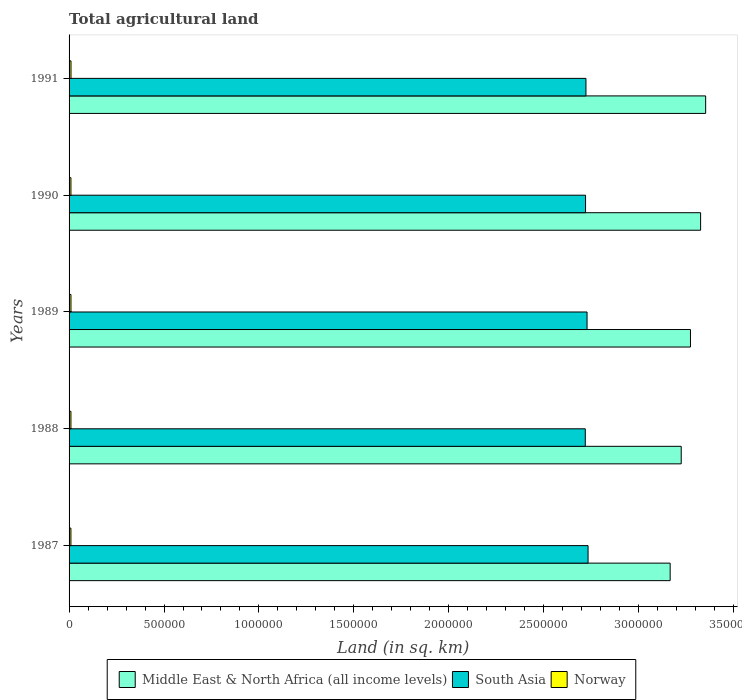Are the number of bars per tick equal to the number of legend labels?
Offer a very short reply. Yes. Are the number of bars on each tick of the Y-axis equal?
Provide a short and direct response. Yes. In how many cases, is the number of bars for a given year not equal to the number of legend labels?
Make the answer very short. 0. What is the total agricultural land in Norway in 1987?
Offer a terse response. 9700. Across all years, what is the maximum total agricultural land in Middle East & North Africa (all income levels)?
Provide a succinct answer. 3.35e+06. Across all years, what is the minimum total agricultural land in South Asia?
Your answer should be very brief. 2.72e+06. In which year was the total agricultural land in Middle East & North Africa (all income levels) minimum?
Give a very brief answer. 1987. What is the total total agricultural land in Norway in the graph?
Ensure brevity in your answer.  4.92e+04. What is the difference between the total agricultural land in Norway in 1987 and that in 1988?
Offer a terse response. -60. What is the difference between the total agricultural land in Middle East & North Africa (all income levels) in 1987 and the total agricultural land in South Asia in 1988?
Ensure brevity in your answer.  4.47e+05. What is the average total agricultural land in South Asia per year?
Offer a terse response. 2.72e+06. In the year 1989, what is the difference between the total agricultural land in Middle East & North Africa (all income levels) and total agricultural land in South Asia?
Ensure brevity in your answer.  5.45e+05. In how many years, is the total agricultural land in South Asia greater than 3000000 sq.km?
Make the answer very short. 0. What is the ratio of the total agricultural land in South Asia in 1987 to that in 1990?
Offer a very short reply. 1. Is the total agricultural land in Norway in 1989 less than that in 1991?
Ensure brevity in your answer.  Yes. What is the difference between the highest and the second highest total agricultural land in Middle East & North Africa (all income levels)?
Make the answer very short. 2.66e+04. Is the sum of the total agricultural land in Middle East & North Africa (all income levels) in 1988 and 1990 greater than the maximum total agricultural land in South Asia across all years?
Offer a very short reply. Yes. What does the 3rd bar from the top in 1989 represents?
Offer a very short reply. Middle East & North Africa (all income levels). Is it the case that in every year, the sum of the total agricultural land in Norway and total agricultural land in South Asia is greater than the total agricultural land in Middle East & North Africa (all income levels)?
Provide a short and direct response. No. How many years are there in the graph?
Make the answer very short. 5. What is the difference between two consecutive major ticks on the X-axis?
Give a very brief answer. 5.00e+05. How are the legend labels stacked?
Keep it short and to the point. Horizontal. What is the title of the graph?
Your answer should be compact. Total agricultural land. Does "Belarus" appear as one of the legend labels in the graph?
Your response must be concise. No. What is the label or title of the X-axis?
Your answer should be compact. Land (in sq. km). What is the Land (in sq. km) in Middle East & North Africa (all income levels) in 1987?
Keep it short and to the point. 3.17e+06. What is the Land (in sq. km) in South Asia in 1987?
Provide a succinct answer. 2.73e+06. What is the Land (in sq. km) in Norway in 1987?
Offer a very short reply. 9700. What is the Land (in sq. km) of Middle East & North Africa (all income levels) in 1988?
Offer a very short reply. 3.22e+06. What is the Land (in sq. km) in South Asia in 1988?
Your answer should be very brief. 2.72e+06. What is the Land (in sq. km) of Norway in 1988?
Offer a very short reply. 9760. What is the Land (in sq. km) of Middle East & North Africa (all income levels) in 1989?
Your answer should be compact. 3.27e+06. What is the Land (in sq. km) in South Asia in 1989?
Offer a very short reply. 2.73e+06. What is the Land (in sq. km) in Norway in 1989?
Offer a very short reply. 9910. What is the Land (in sq. km) in Middle East & North Africa (all income levels) in 1990?
Provide a succinct answer. 3.33e+06. What is the Land (in sq. km) in South Asia in 1990?
Your response must be concise. 2.72e+06. What is the Land (in sq. km) of Norway in 1990?
Ensure brevity in your answer.  9760. What is the Land (in sq. km) of Middle East & North Africa (all income levels) in 1991?
Ensure brevity in your answer.  3.35e+06. What is the Land (in sq. km) in South Asia in 1991?
Your answer should be compact. 2.72e+06. What is the Land (in sq. km) of Norway in 1991?
Your answer should be compact. 1.01e+04. Across all years, what is the maximum Land (in sq. km) of Middle East & North Africa (all income levels)?
Provide a short and direct response. 3.35e+06. Across all years, what is the maximum Land (in sq. km) in South Asia?
Your answer should be compact. 2.73e+06. Across all years, what is the maximum Land (in sq. km) in Norway?
Your answer should be very brief. 1.01e+04. Across all years, what is the minimum Land (in sq. km) of Middle East & North Africa (all income levels)?
Offer a very short reply. 3.17e+06. Across all years, what is the minimum Land (in sq. km) in South Asia?
Offer a very short reply. 2.72e+06. Across all years, what is the minimum Land (in sq. km) in Norway?
Give a very brief answer. 9700. What is the total Land (in sq. km) in Middle East & North Africa (all income levels) in the graph?
Provide a succinct answer. 1.63e+07. What is the total Land (in sq. km) in South Asia in the graph?
Your answer should be very brief. 1.36e+07. What is the total Land (in sq. km) in Norway in the graph?
Provide a succinct answer. 4.92e+04. What is the difference between the Land (in sq. km) in Middle East & North Africa (all income levels) in 1987 and that in 1988?
Provide a succinct answer. -5.83e+04. What is the difference between the Land (in sq. km) in South Asia in 1987 and that in 1988?
Ensure brevity in your answer.  1.47e+04. What is the difference between the Land (in sq. km) in Norway in 1987 and that in 1988?
Your response must be concise. -60. What is the difference between the Land (in sq. km) in Middle East & North Africa (all income levels) in 1987 and that in 1989?
Your response must be concise. -1.07e+05. What is the difference between the Land (in sq. km) in South Asia in 1987 and that in 1989?
Keep it short and to the point. 5308. What is the difference between the Land (in sq. km) in Norway in 1987 and that in 1989?
Provide a short and direct response. -210. What is the difference between the Land (in sq. km) of Middle East & North Africa (all income levels) in 1987 and that in 1990?
Your answer should be compact. -1.60e+05. What is the difference between the Land (in sq. km) in South Asia in 1987 and that in 1990?
Ensure brevity in your answer.  1.33e+04. What is the difference between the Land (in sq. km) in Norway in 1987 and that in 1990?
Keep it short and to the point. -60. What is the difference between the Land (in sq. km) of Middle East & North Africa (all income levels) in 1987 and that in 1991?
Your answer should be very brief. -1.87e+05. What is the difference between the Land (in sq. km) in South Asia in 1987 and that in 1991?
Make the answer very short. 1.11e+04. What is the difference between the Land (in sq. km) of Norway in 1987 and that in 1991?
Make the answer very short. -400. What is the difference between the Land (in sq. km) in Middle East & North Africa (all income levels) in 1988 and that in 1989?
Provide a succinct answer. -4.87e+04. What is the difference between the Land (in sq. km) of South Asia in 1988 and that in 1989?
Give a very brief answer. -9366. What is the difference between the Land (in sq. km) of Norway in 1988 and that in 1989?
Make the answer very short. -150. What is the difference between the Land (in sq. km) in Middle East & North Africa (all income levels) in 1988 and that in 1990?
Offer a very short reply. -1.02e+05. What is the difference between the Land (in sq. km) of South Asia in 1988 and that in 1990?
Ensure brevity in your answer.  -1422. What is the difference between the Land (in sq. km) in Middle East & North Africa (all income levels) in 1988 and that in 1991?
Your answer should be very brief. -1.29e+05. What is the difference between the Land (in sq. km) in South Asia in 1988 and that in 1991?
Make the answer very short. -3588. What is the difference between the Land (in sq. km) in Norway in 1988 and that in 1991?
Ensure brevity in your answer.  -340. What is the difference between the Land (in sq. km) in Middle East & North Africa (all income levels) in 1989 and that in 1990?
Your answer should be compact. -5.34e+04. What is the difference between the Land (in sq. km) in South Asia in 1989 and that in 1990?
Your answer should be very brief. 7944. What is the difference between the Land (in sq. km) in Norway in 1989 and that in 1990?
Offer a terse response. 150. What is the difference between the Land (in sq. km) of Middle East & North Africa (all income levels) in 1989 and that in 1991?
Your response must be concise. -8.00e+04. What is the difference between the Land (in sq. km) of South Asia in 1989 and that in 1991?
Your response must be concise. 5778. What is the difference between the Land (in sq. km) in Norway in 1989 and that in 1991?
Ensure brevity in your answer.  -190. What is the difference between the Land (in sq. km) in Middle East & North Africa (all income levels) in 1990 and that in 1991?
Give a very brief answer. -2.66e+04. What is the difference between the Land (in sq. km) of South Asia in 1990 and that in 1991?
Your answer should be very brief. -2166. What is the difference between the Land (in sq. km) in Norway in 1990 and that in 1991?
Offer a terse response. -340. What is the difference between the Land (in sq. km) of Middle East & North Africa (all income levels) in 1987 and the Land (in sq. km) of South Asia in 1988?
Provide a short and direct response. 4.47e+05. What is the difference between the Land (in sq. km) in Middle East & North Africa (all income levels) in 1987 and the Land (in sq. km) in Norway in 1988?
Provide a succinct answer. 3.16e+06. What is the difference between the Land (in sq. km) of South Asia in 1987 and the Land (in sq. km) of Norway in 1988?
Give a very brief answer. 2.72e+06. What is the difference between the Land (in sq. km) in Middle East & North Africa (all income levels) in 1987 and the Land (in sq. km) in South Asia in 1989?
Your response must be concise. 4.38e+05. What is the difference between the Land (in sq. km) in Middle East & North Africa (all income levels) in 1987 and the Land (in sq. km) in Norway in 1989?
Provide a short and direct response. 3.16e+06. What is the difference between the Land (in sq. km) of South Asia in 1987 and the Land (in sq. km) of Norway in 1989?
Provide a short and direct response. 2.72e+06. What is the difference between the Land (in sq. km) in Middle East & North Africa (all income levels) in 1987 and the Land (in sq. km) in South Asia in 1990?
Provide a succinct answer. 4.46e+05. What is the difference between the Land (in sq. km) in Middle East & North Africa (all income levels) in 1987 and the Land (in sq. km) in Norway in 1990?
Make the answer very short. 3.16e+06. What is the difference between the Land (in sq. km) in South Asia in 1987 and the Land (in sq. km) in Norway in 1990?
Your answer should be compact. 2.72e+06. What is the difference between the Land (in sq. km) in Middle East & North Africa (all income levels) in 1987 and the Land (in sq. km) in South Asia in 1991?
Your answer should be compact. 4.43e+05. What is the difference between the Land (in sq. km) of Middle East & North Africa (all income levels) in 1987 and the Land (in sq. km) of Norway in 1991?
Keep it short and to the point. 3.16e+06. What is the difference between the Land (in sq. km) in South Asia in 1987 and the Land (in sq. km) in Norway in 1991?
Offer a terse response. 2.72e+06. What is the difference between the Land (in sq. km) in Middle East & North Africa (all income levels) in 1988 and the Land (in sq. km) in South Asia in 1989?
Keep it short and to the point. 4.96e+05. What is the difference between the Land (in sq. km) of Middle East & North Africa (all income levels) in 1988 and the Land (in sq. km) of Norway in 1989?
Provide a short and direct response. 3.21e+06. What is the difference between the Land (in sq. km) of South Asia in 1988 and the Land (in sq. km) of Norway in 1989?
Your answer should be very brief. 2.71e+06. What is the difference between the Land (in sq. km) in Middle East & North Africa (all income levels) in 1988 and the Land (in sq. km) in South Asia in 1990?
Your answer should be compact. 5.04e+05. What is the difference between the Land (in sq. km) of Middle East & North Africa (all income levels) in 1988 and the Land (in sq. km) of Norway in 1990?
Ensure brevity in your answer.  3.21e+06. What is the difference between the Land (in sq. km) in South Asia in 1988 and the Land (in sq. km) in Norway in 1990?
Keep it short and to the point. 2.71e+06. What is the difference between the Land (in sq. km) in Middle East & North Africa (all income levels) in 1988 and the Land (in sq. km) in South Asia in 1991?
Your answer should be compact. 5.02e+05. What is the difference between the Land (in sq. km) of Middle East & North Africa (all income levels) in 1988 and the Land (in sq. km) of Norway in 1991?
Give a very brief answer. 3.21e+06. What is the difference between the Land (in sq. km) in South Asia in 1988 and the Land (in sq. km) in Norway in 1991?
Make the answer very short. 2.71e+06. What is the difference between the Land (in sq. km) of Middle East & North Africa (all income levels) in 1989 and the Land (in sq. km) of South Asia in 1990?
Ensure brevity in your answer.  5.53e+05. What is the difference between the Land (in sq. km) in Middle East & North Africa (all income levels) in 1989 and the Land (in sq. km) in Norway in 1990?
Offer a very short reply. 3.26e+06. What is the difference between the Land (in sq. km) of South Asia in 1989 and the Land (in sq. km) of Norway in 1990?
Your answer should be very brief. 2.72e+06. What is the difference between the Land (in sq. km) of Middle East & North Africa (all income levels) in 1989 and the Land (in sq. km) of South Asia in 1991?
Keep it short and to the point. 5.50e+05. What is the difference between the Land (in sq. km) of Middle East & North Africa (all income levels) in 1989 and the Land (in sq. km) of Norway in 1991?
Provide a short and direct response. 3.26e+06. What is the difference between the Land (in sq. km) of South Asia in 1989 and the Land (in sq. km) of Norway in 1991?
Offer a terse response. 2.72e+06. What is the difference between the Land (in sq. km) in Middle East & North Africa (all income levels) in 1990 and the Land (in sq. km) in South Asia in 1991?
Give a very brief answer. 6.04e+05. What is the difference between the Land (in sq. km) of Middle East & North Africa (all income levels) in 1990 and the Land (in sq. km) of Norway in 1991?
Ensure brevity in your answer.  3.32e+06. What is the difference between the Land (in sq. km) in South Asia in 1990 and the Land (in sq. km) in Norway in 1991?
Provide a short and direct response. 2.71e+06. What is the average Land (in sq. km) of Middle East & North Africa (all income levels) per year?
Provide a short and direct response. 3.27e+06. What is the average Land (in sq. km) of South Asia per year?
Offer a very short reply. 2.72e+06. What is the average Land (in sq. km) of Norway per year?
Your answer should be compact. 9846. In the year 1987, what is the difference between the Land (in sq. km) in Middle East & North Africa (all income levels) and Land (in sq. km) in South Asia?
Give a very brief answer. 4.32e+05. In the year 1987, what is the difference between the Land (in sq. km) in Middle East & North Africa (all income levels) and Land (in sq. km) in Norway?
Offer a terse response. 3.16e+06. In the year 1987, what is the difference between the Land (in sq. km) of South Asia and Land (in sq. km) of Norway?
Your answer should be very brief. 2.72e+06. In the year 1988, what is the difference between the Land (in sq. km) in Middle East & North Africa (all income levels) and Land (in sq. km) in South Asia?
Keep it short and to the point. 5.05e+05. In the year 1988, what is the difference between the Land (in sq. km) in Middle East & North Africa (all income levels) and Land (in sq. km) in Norway?
Provide a short and direct response. 3.21e+06. In the year 1988, what is the difference between the Land (in sq. km) in South Asia and Land (in sq. km) in Norway?
Keep it short and to the point. 2.71e+06. In the year 1989, what is the difference between the Land (in sq. km) in Middle East & North Africa (all income levels) and Land (in sq. km) in South Asia?
Keep it short and to the point. 5.45e+05. In the year 1989, what is the difference between the Land (in sq. km) of Middle East & North Africa (all income levels) and Land (in sq. km) of Norway?
Make the answer very short. 3.26e+06. In the year 1989, what is the difference between the Land (in sq. km) in South Asia and Land (in sq. km) in Norway?
Give a very brief answer. 2.72e+06. In the year 1990, what is the difference between the Land (in sq. km) in Middle East & North Africa (all income levels) and Land (in sq. km) in South Asia?
Make the answer very short. 6.06e+05. In the year 1990, what is the difference between the Land (in sq. km) of Middle East & North Africa (all income levels) and Land (in sq. km) of Norway?
Provide a short and direct response. 3.32e+06. In the year 1990, what is the difference between the Land (in sq. km) of South Asia and Land (in sq. km) of Norway?
Offer a terse response. 2.71e+06. In the year 1991, what is the difference between the Land (in sq. km) of Middle East & North Africa (all income levels) and Land (in sq. km) of South Asia?
Provide a succinct answer. 6.30e+05. In the year 1991, what is the difference between the Land (in sq. km) of Middle East & North Africa (all income levels) and Land (in sq. km) of Norway?
Your answer should be very brief. 3.34e+06. In the year 1991, what is the difference between the Land (in sq. km) of South Asia and Land (in sq. km) of Norway?
Offer a terse response. 2.71e+06. What is the ratio of the Land (in sq. km) in Middle East & North Africa (all income levels) in 1987 to that in 1988?
Offer a terse response. 0.98. What is the ratio of the Land (in sq. km) in South Asia in 1987 to that in 1988?
Offer a terse response. 1.01. What is the ratio of the Land (in sq. km) in Norway in 1987 to that in 1988?
Provide a short and direct response. 0.99. What is the ratio of the Land (in sq. km) of Middle East & North Africa (all income levels) in 1987 to that in 1989?
Your answer should be compact. 0.97. What is the ratio of the Land (in sq. km) of South Asia in 1987 to that in 1989?
Ensure brevity in your answer.  1. What is the ratio of the Land (in sq. km) of Norway in 1987 to that in 1989?
Make the answer very short. 0.98. What is the ratio of the Land (in sq. km) of Middle East & North Africa (all income levels) in 1987 to that in 1990?
Give a very brief answer. 0.95. What is the ratio of the Land (in sq. km) in South Asia in 1987 to that in 1990?
Give a very brief answer. 1. What is the ratio of the Land (in sq. km) in Middle East & North Africa (all income levels) in 1987 to that in 1991?
Offer a very short reply. 0.94. What is the ratio of the Land (in sq. km) of Norway in 1987 to that in 1991?
Keep it short and to the point. 0.96. What is the ratio of the Land (in sq. km) of Middle East & North Africa (all income levels) in 1988 to that in 1989?
Offer a very short reply. 0.99. What is the ratio of the Land (in sq. km) in South Asia in 1988 to that in 1989?
Keep it short and to the point. 1. What is the ratio of the Land (in sq. km) of Norway in 1988 to that in 1989?
Provide a succinct answer. 0.98. What is the ratio of the Land (in sq. km) in Middle East & North Africa (all income levels) in 1988 to that in 1990?
Your response must be concise. 0.97. What is the ratio of the Land (in sq. km) of South Asia in 1988 to that in 1990?
Your answer should be compact. 1. What is the ratio of the Land (in sq. km) of Norway in 1988 to that in 1990?
Offer a terse response. 1. What is the ratio of the Land (in sq. km) of Middle East & North Africa (all income levels) in 1988 to that in 1991?
Give a very brief answer. 0.96. What is the ratio of the Land (in sq. km) of South Asia in 1988 to that in 1991?
Your response must be concise. 1. What is the ratio of the Land (in sq. km) in Norway in 1988 to that in 1991?
Your response must be concise. 0.97. What is the ratio of the Land (in sq. km) of Middle East & North Africa (all income levels) in 1989 to that in 1990?
Ensure brevity in your answer.  0.98. What is the ratio of the Land (in sq. km) of South Asia in 1989 to that in 1990?
Your answer should be compact. 1. What is the ratio of the Land (in sq. km) of Norway in 1989 to that in 1990?
Make the answer very short. 1.02. What is the ratio of the Land (in sq. km) in Middle East & North Africa (all income levels) in 1989 to that in 1991?
Offer a terse response. 0.98. What is the ratio of the Land (in sq. km) in South Asia in 1989 to that in 1991?
Provide a succinct answer. 1. What is the ratio of the Land (in sq. km) of Norway in 1989 to that in 1991?
Keep it short and to the point. 0.98. What is the ratio of the Land (in sq. km) in Middle East & North Africa (all income levels) in 1990 to that in 1991?
Keep it short and to the point. 0.99. What is the ratio of the Land (in sq. km) in Norway in 1990 to that in 1991?
Give a very brief answer. 0.97. What is the difference between the highest and the second highest Land (in sq. km) of Middle East & North Africa (all income levels)?
Give a very brief answer. 2.66e+04. What is the difference between the highest and the second highest Land (in sq. km) in South Asia?
Your answer should be compact. 5308. What is the difference between the highest and the second highest Land (in sq. km) in Norway?
Give a very brief answer. 190. What is the difference between the highest and the lowest Land (in sq. km) in Middle East & North Africa (all income levels)?
Your response must be concise. 1.87e+05. What is the difference between the highest and the lowest Land (in sq. km) in South Asia?
Keep it short and to the point. 1.47e+04. 